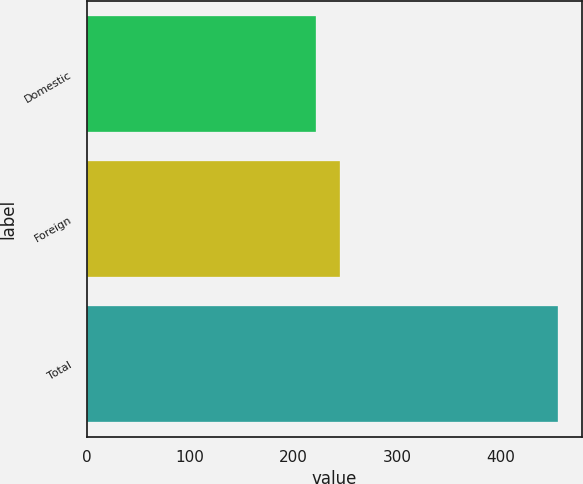Convert chart to OTSL. <chart><loc_0><loc_0><loc_500><loc_500><bar_chart><fcel>Domestic<fcel>Foreign<fcel>Total<nl><fcel>221.8<fcel>245.22<fcel>456<nl></chart> 